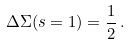<formula> <loc_0><loc_0><loc_500><loc_500>\Delta \Sigma ( s = 1 ) = \frac { 1 } { 2 } \, .</formula> 